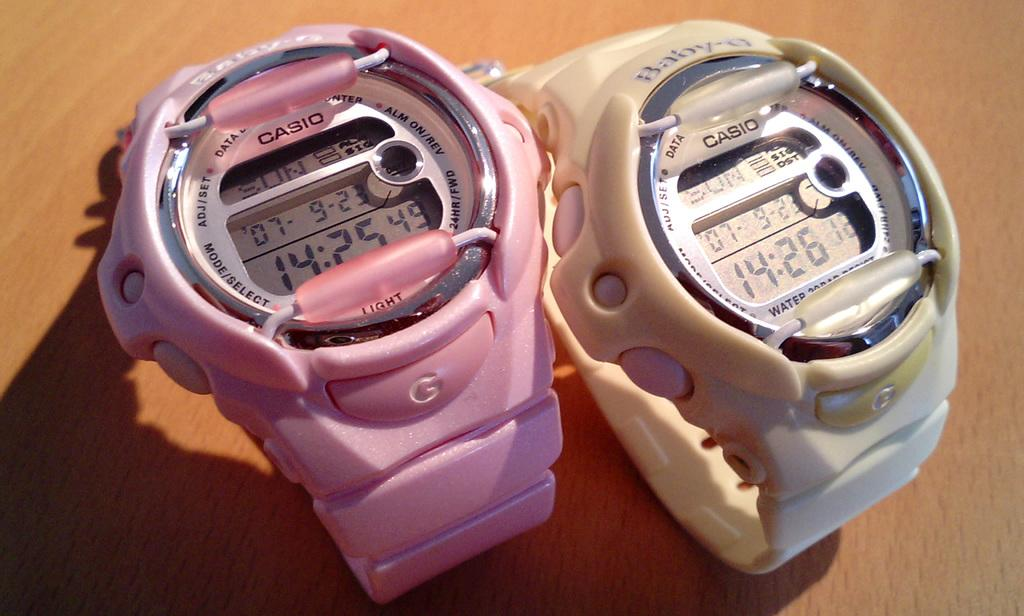<image>
Summarize the visual content of the image. Two rubber watches that both have the letter G on them 